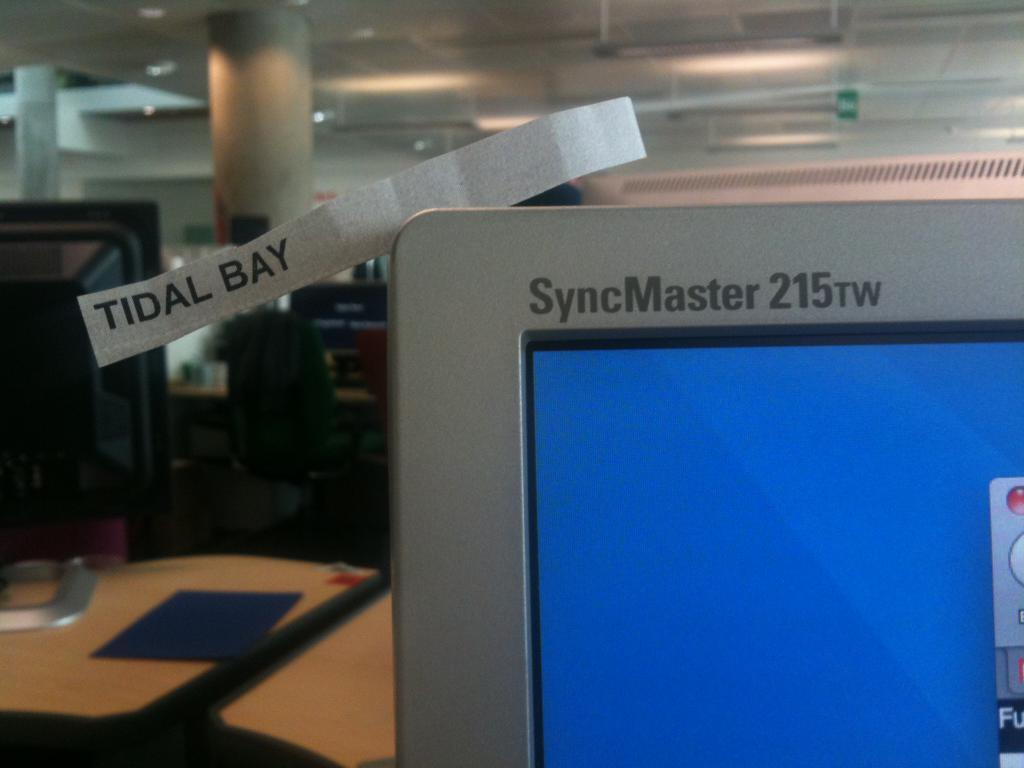<image>
Give a short and clear explanation of the subsequent image. the syncmaster 215 computer is on a blue screen 